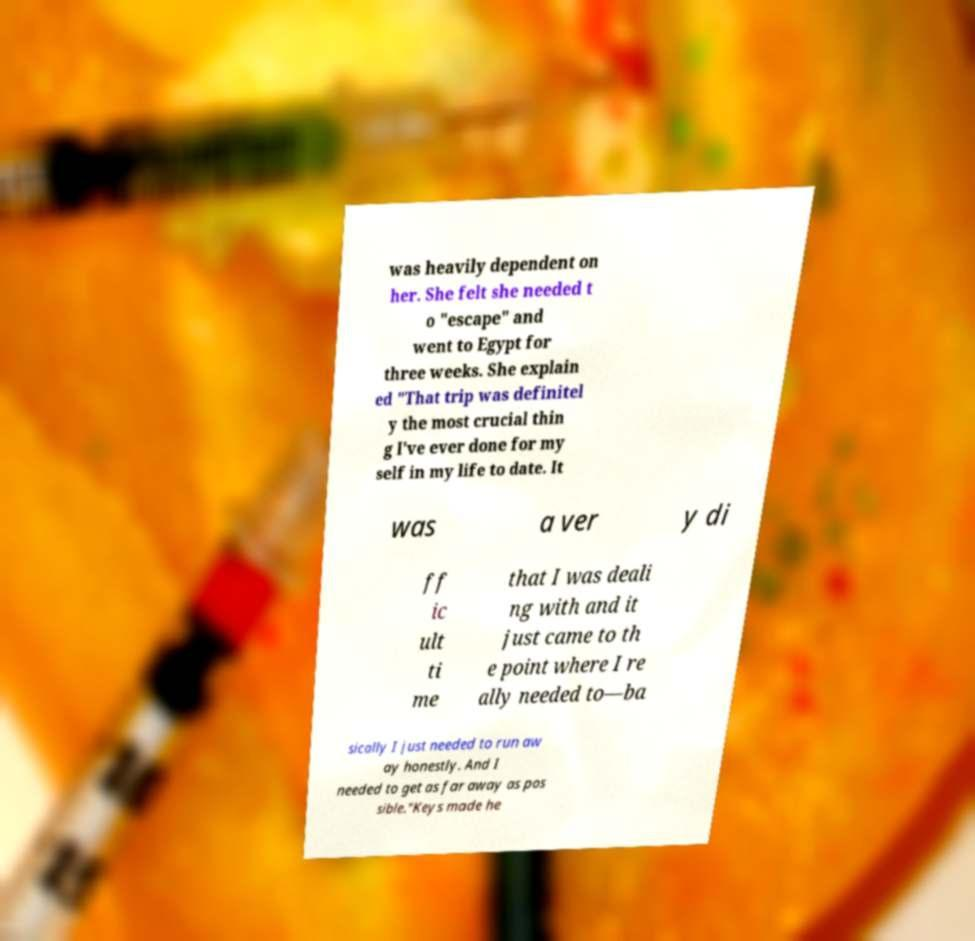Could you assist in decoding the text presented in this image and type it out clearly? was heavily dependent on her. She felt she needed t o "escape" and went to Egypt for three weeks. She explain ed "That trip was definitel y the most crucial thin g I've ever done for my self in my life to date. It was a ver y di ff ic ult ti me that I was deali ng with and it just came to th e point where I re ally needed to—ba sically I just needed to run aw ay honestly. And I needed to get as far away as pos sible."Keys made he 